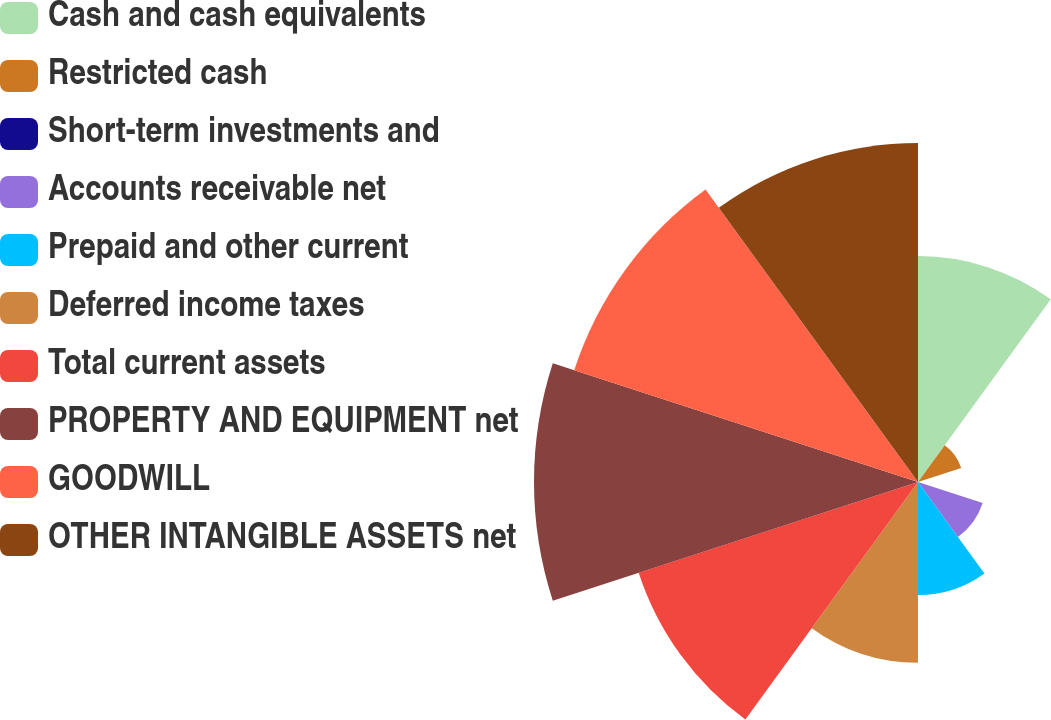Convert chart to OTSL. <chart><loc_0><loc_0><loc_500><loc_500><pie_chart><fcel>Cash and cash equivalents<fcel>Restricted cash<fcel>Short-term investments and<fcel>Accounts receivable net<fcel>Prepaid and other current<fcel>Deferred income taxes<fcel>Total current assets<fcel>PROPERTY AND EQUIPMENT net<fcel>GOODWILL<fcel>OTHER INTANGIBLE ASSETS net<nl><fcel>11.23%<fcel>2.26%<fcel>0.01%<fcel>3.38%<fcel>5.62%<fcel>8.99%<fcel>14.6%<fcel>19.09%<fcel>17.97%<fcel>16.85%<nl></chart> 